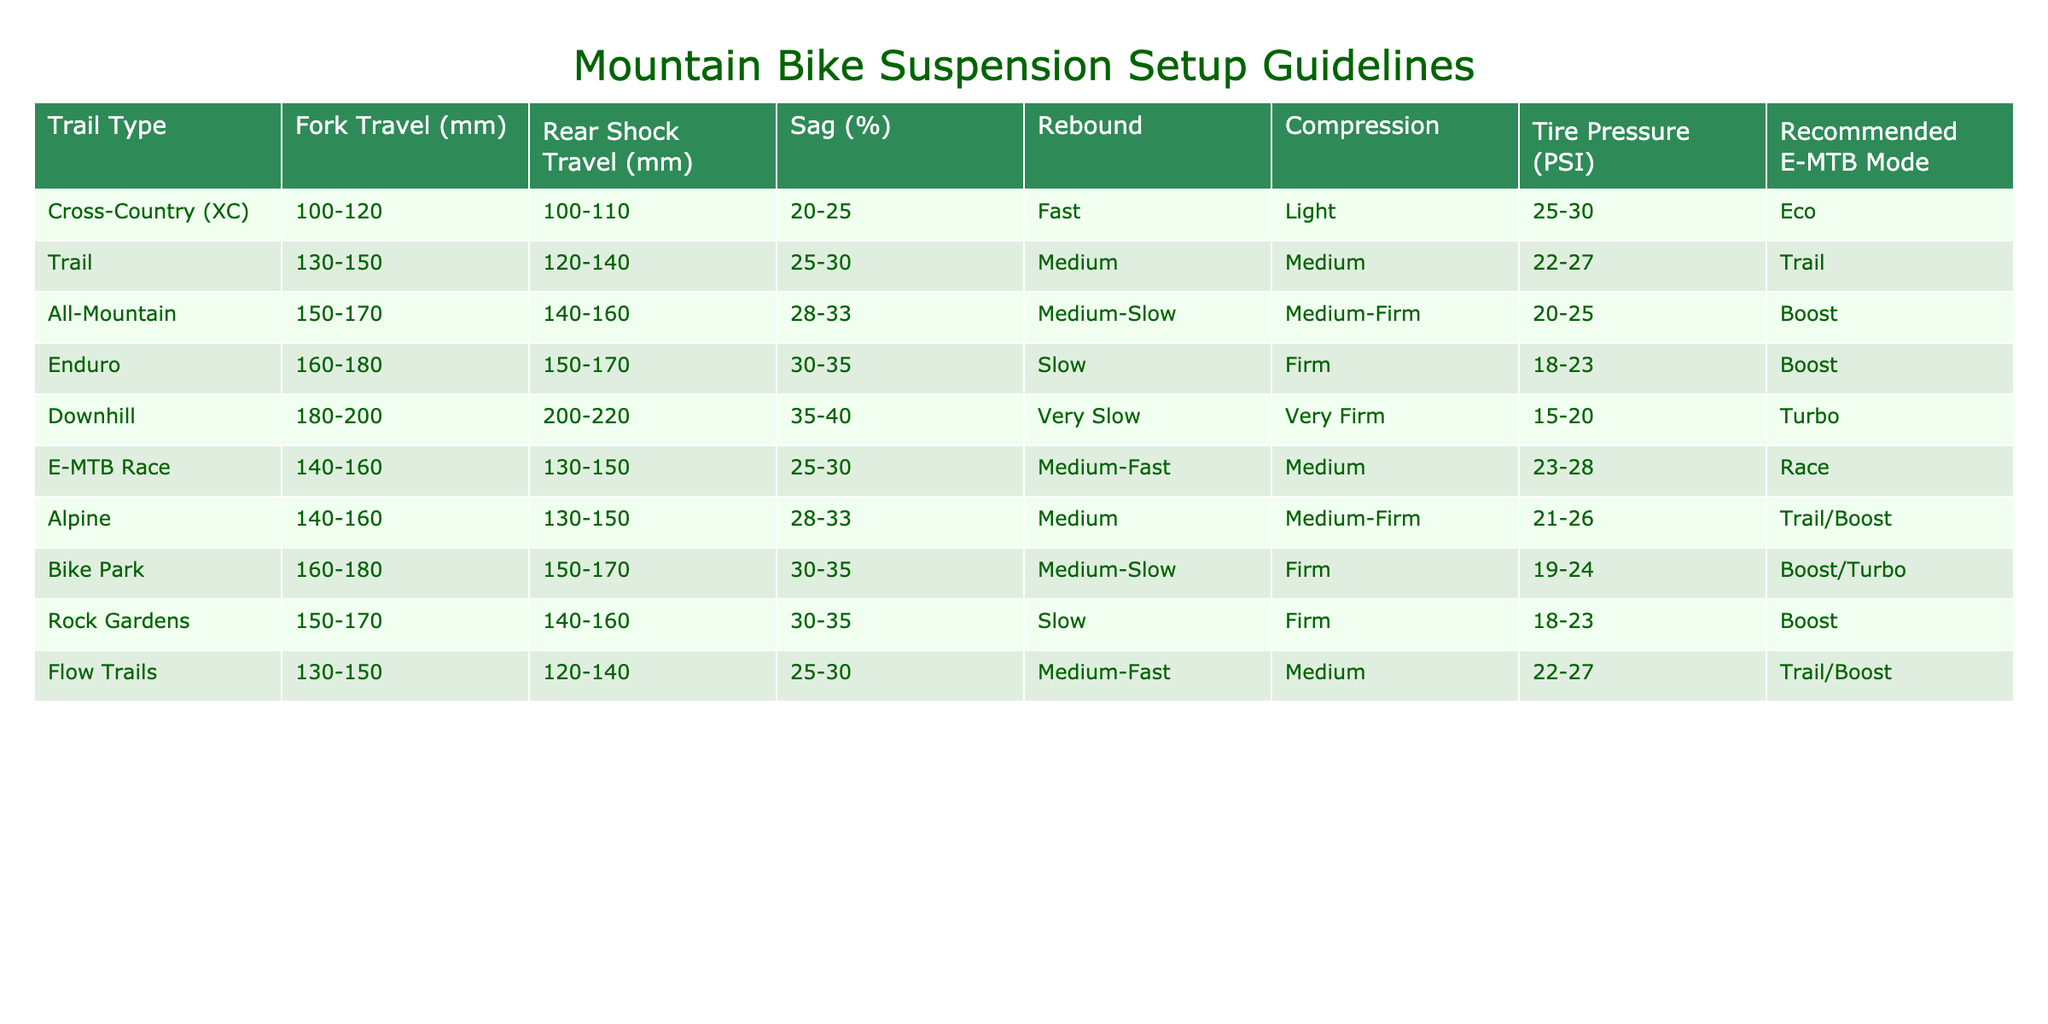What is the recommended tire pressure for Cross-Country trails? The table lists the tire pressure for Cross-Country trails as 25-30 PSI.
Answer: 25-30 PSI How much sag is recommended for Enduro bikes? The table indicates that the recommended sag for Enduro bikes is 30-35%.
Answer: 30-35% Is the fork travel for Trail bikes greater than 120 mm? The table shows that the fork travel for Trail bikes ranges from 130-150 mm, which is indeed greater than 120 mm.
Answer: Yes What is the average fork travel for All-Mountain and Trail trail types? The fork travel for All-Mountain is 150-170 mm (average 160 mm) and for Trail it's 130-150 mm (average 140 mm). To find the overall average, we combine these averages: (160 + 140) / 2 = 150 mm.
Answer: 150 mm Which trail type has the highest recommended e-MTB mode? Looking at the table, Downhill has a recommended e-MTB mode of Turbo, which is higher than the others that are Eco, Trail, Boost, or Race.
Answer: Turbo How does the recommended compression setting for Bike Park compare to that of Flow Trails? The Bike Park has a recommended compression setting of Firm, while Flow Trails are at Medium. Firm is stronger compared to Medium. Therefore, Bike Park has a more rigid setup.
Answer: Bike Park's setting is firmer Is it true that Alpine trail type has a lower rear shock travel than Downhill? According to the table, Alpine has a rear shock travel of 130-150 mm, while Downhill has a travel of 200-220 mm. So yes, Alpine does have a lower rear shock travel than Downhill.
Answer: Yes What is the range of sag percentages for Cross-Country trails compared to All-Mountain trails? Cross-Country has a sag range of 20-25%, while All-Mountain has 28-33%. To compare, All-Mountain has a higher percentage range than Cross-Country.
Answer: All-Mountain has a higher range 